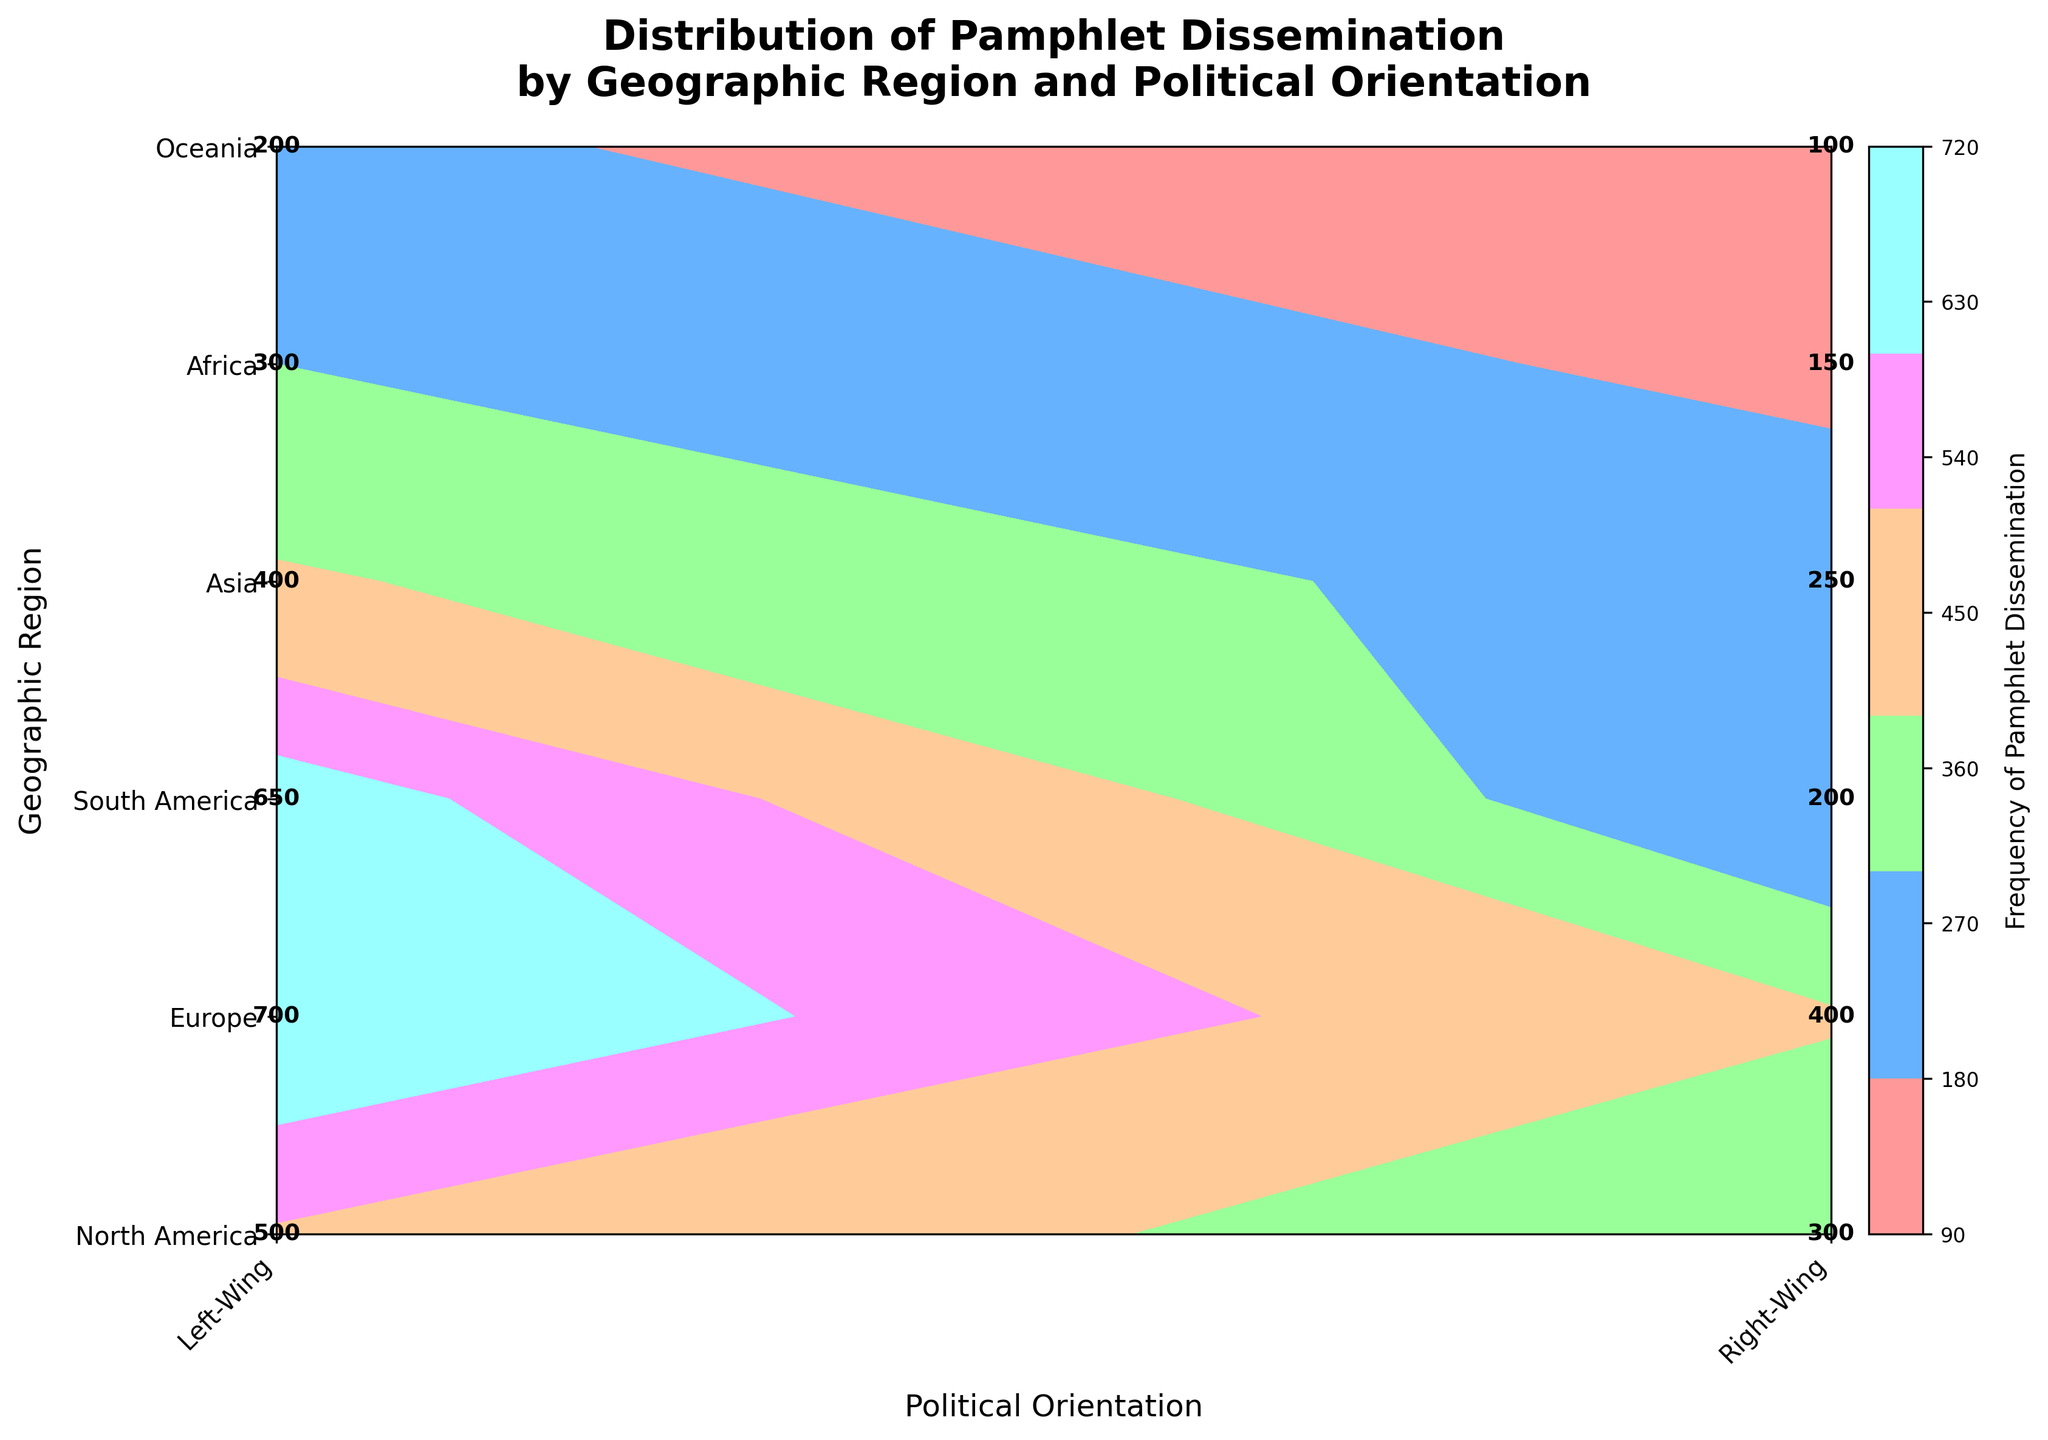What's the title of the plot? The title of the plot is displayed at the top of the figure and is often used to provide context for the viewer, making it easier to understand the data being presented.
Answer: Distribution of Pamphlet Dissemination by Geographic Region and Political Orientation Which geographic region has the highest frequency of pamphlet dissemination for left-wing movements? Look at the highest value in the left-wing column. In Europe, which is represented as having a frequency value of 700.
Answer: Europe Which political orientation, left-wing or right-wing, generally shows higher frequencies of pamphlet dissemination across all regions? Compare the frequency values across all regions for both left-wing and right-wing columns. Left-wing values are consistently higher: North America (500 vs. 300), Europe (700 vs. 400), South America (650 vs. 200), Asia (400 vs. 250), Africa (300 vs. 150), Oceania (200 vs. 100).
Answer: Left-wing What's the frequency difference of pamphlet dissemination between the left-wing and the right-wing in South America? Subtract the right-wing frequency from the left-wing frequency in South America: 650 - 200 = 450.
Answer: 450 What's the average frequency of pamphlet dissemination in North America? Add the frequency of left-wing (500) and right-wing (300) pamphlet dissemination in North America, then divide by 2 to find the average: (500 + 300) / 2 = 400.
Answer: 400 Which geographic region has the lowest frequency of pamphlet dissemination for right-wing movements? Look for the smallest value in the right-wing column which is for Oceania with a frequency of 100.
Answer: Oceania How does the frequency of right-wing pamphlet dissemination in Europe compare to that in Asia? Compare the frequency values for right-wing movements in Europe and Asia. Europe has a higher frequency (400) compared to Asia (250).
Answer: Europe has more What's the total frequency of pamphlet dissemination across all regions for left-wing movements? Sum the left-wing frequencies from all regions: 500 (North America) + 700 (Europe) + 650 (South America) + 400 (Asia) + 300 (Africa) + 200 (Oceania) = 2750.
Answer: 2750 In which region is the disparity between left-wing and right-wing pamphlet dissemination smallest? Calculate the differences between left-wing and right-wing dissemination for each region, and find the smallest disparity: North America (200), Europe (300), South America (450), Asia (150), Africa (150), Oceania (100). The smallest disparity is in Oceania (100).
Answer: Oceania 